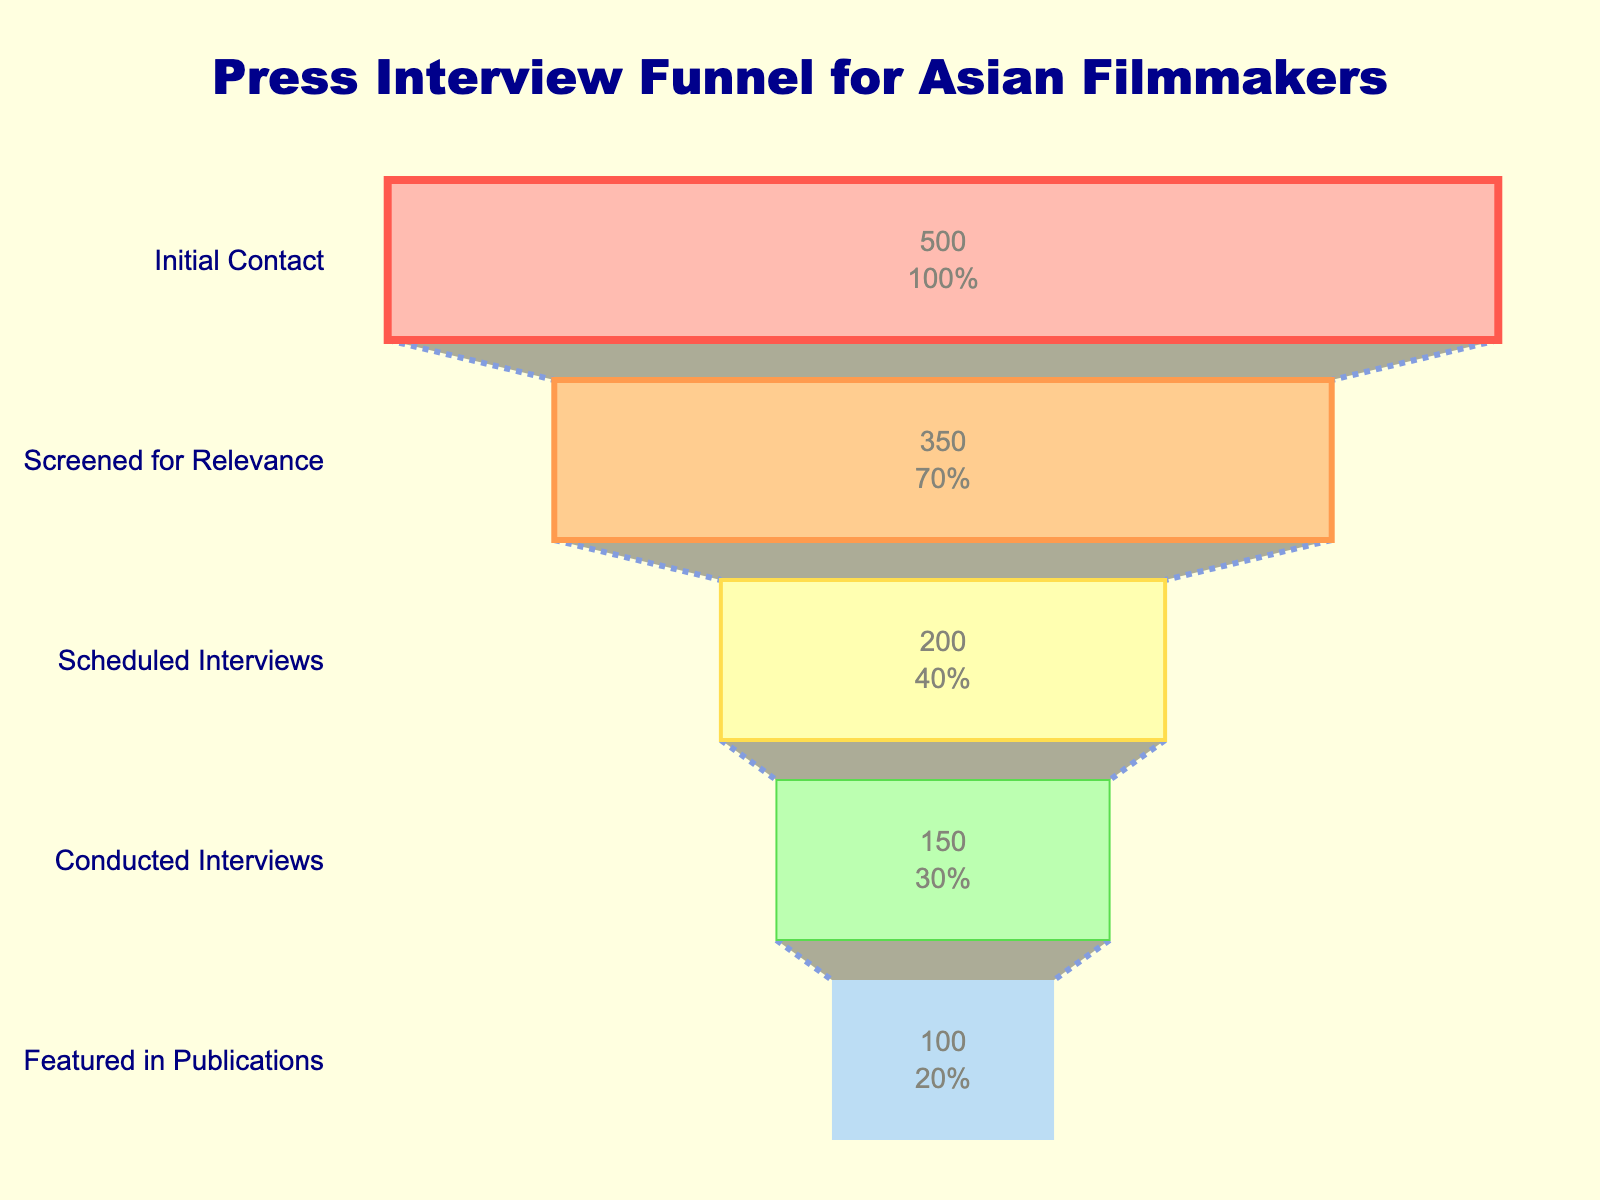what is the title of the figure? The title of the figure is located at the top and reads "Press Interview Funnel for Asian Filmmakers," which provides context about the data presented.
Answer: Press Interview Funnel for Asian Filmmakers What are the five stages identified in the funnel chart? The five stages are listed in descending order in the chart as "Initial Contact," "Screened for Relevance," "Scheduled Interviews," "Conducted Interviews," and "Featured in Publications."
Answer: Initial Contact, Screened for Relevance, Scheduled Interviews, Conducted Interviews, Featured in Publications How many requests are there at the "Scheduled Interviews" stage? By referring to the chart, the "Scheduled Interviews" stage shows the number 200 inside the funnel.
Answer: 200 What percentage of the initial contacts go on to be featured in publications? The initial contacts are 500. The number featured in publications is 100. Calculate the percentage as (100/500) * 100 = 20%.
Answer: 20% What is the difference between the number of requests at the "Initial Contact" and "Conducted Interviews" stages? Subtract the number of requests at "Conducted Interviews" (150) from the "Initial Contact" (500): 500 - 150 = 350.
Answer: 350 Which stage has the highest dropout rate between the previous stage and itself? By looking at the differences between each stage, the greatest drop-off is from "Screened for Relevance" (350) to "Scheduled Interviews" (200), which is a drop of 150.
Answer: Screened for Relevance to Scheduled Interviews What is the percentage passed from "Screened for Relevance" to "Conducted Interviews"? The number screened is 350, and the number conducted interviews is 150. Calculate the percentage: (150/350) * 100 = ~42.86%.
Answer: ~42.86% How does the color scheme transition from the start to the end of the funnel? The color transitions from a reddish-pink color for "Initial Contact" to a blue color for "Featured in Publications," indicating a gradient effect from warm to cool colors.
Answer: Gradient from reddish-pink to blue What stage has the smallest number of requests? Referring to the chart, the "Featured in Publications" stage has the smallest number of requests, which is 100.
Answer: Featured in Publications Why do most interview requests not make it to the "Featured in Publications" stage? The funnel chart reveals significant drop-offs at each stage, indicating that many requests are filtered out due to relevance, scheduling conflicts, and possibly the quality of the interview content.
Answer: Multiple filters and challenges at each stage 